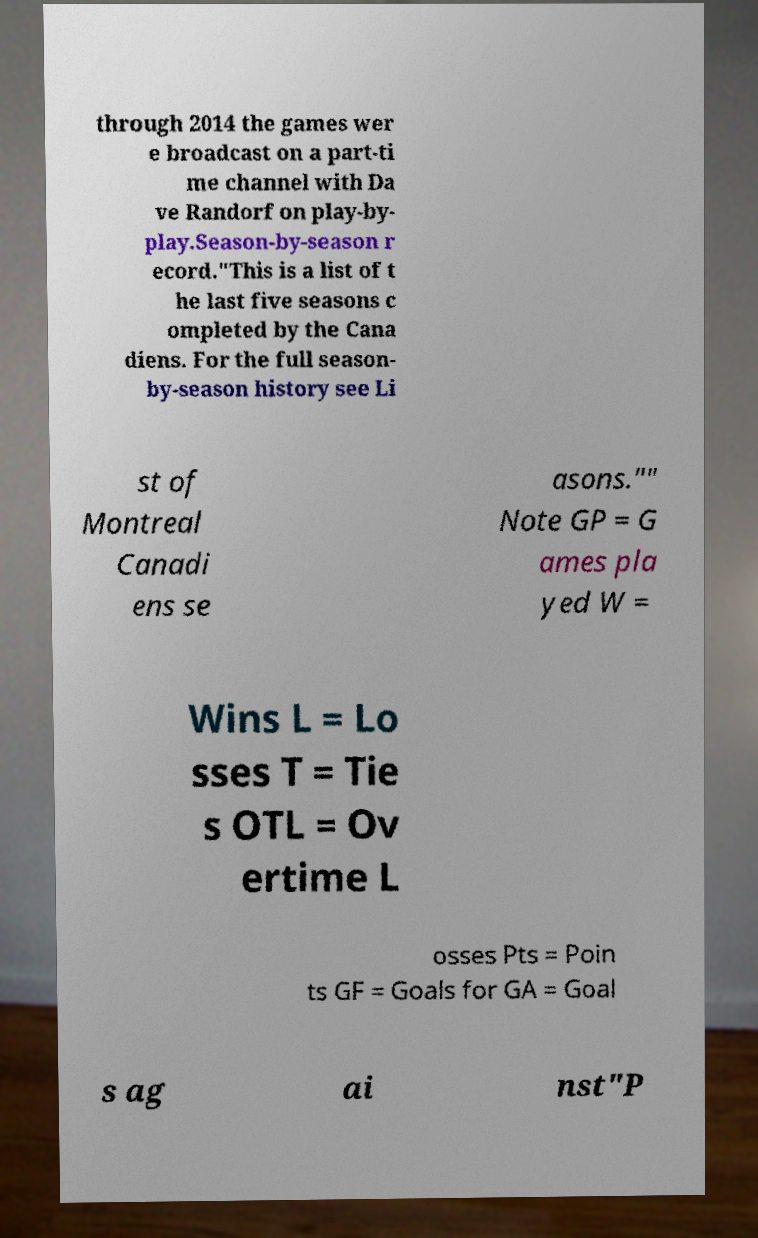Can you read and provide the text displayed in the image?This photo seems to have some interesting text. Can you extract and type it out for me? through 2014 the games wer e broadcast on a part-ti me channel with Da ve Randorf on play-by- play.Season-by-season r ecord."This is a list of t he last five seasons c ompleted by the Cana diens. For the full season- by-season history see Li st of Montreal Canadi ens se asons."" Note GP = G ames pla yed W = Wins L = Lo sses T = Tie s OTL = Ov ertime L osses Pts = Poin ts GF = Goals for GA = Goal s ag ai nst"P 